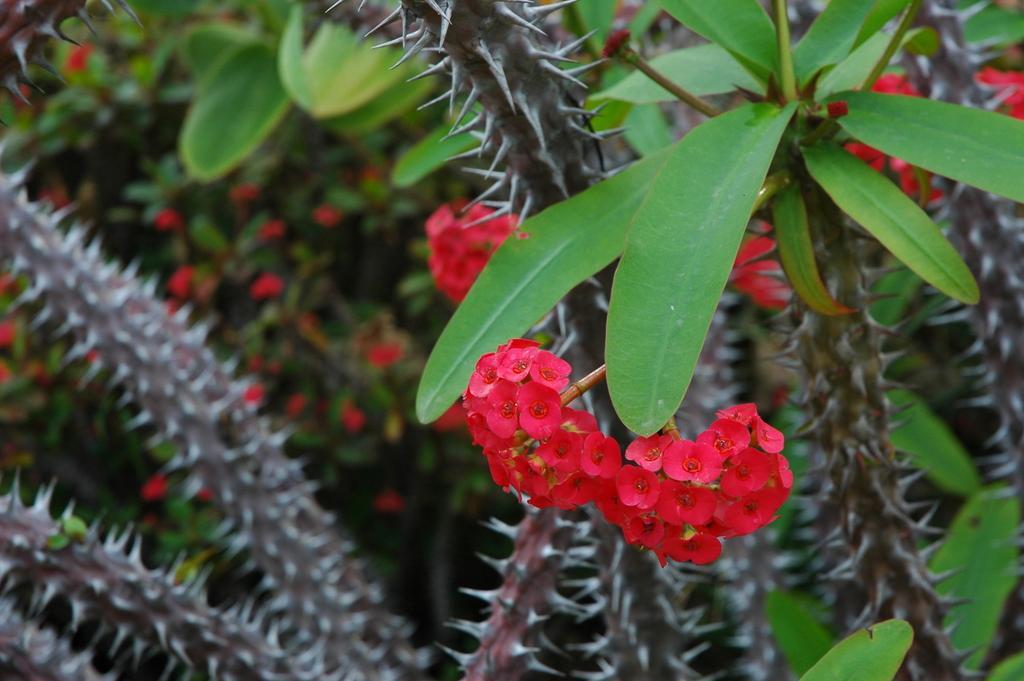Can you describe this image briefly? In this picture I can see some small red flowers on the plant. In the back I can see the blur image. At the bottom I can see the cactus plant. 